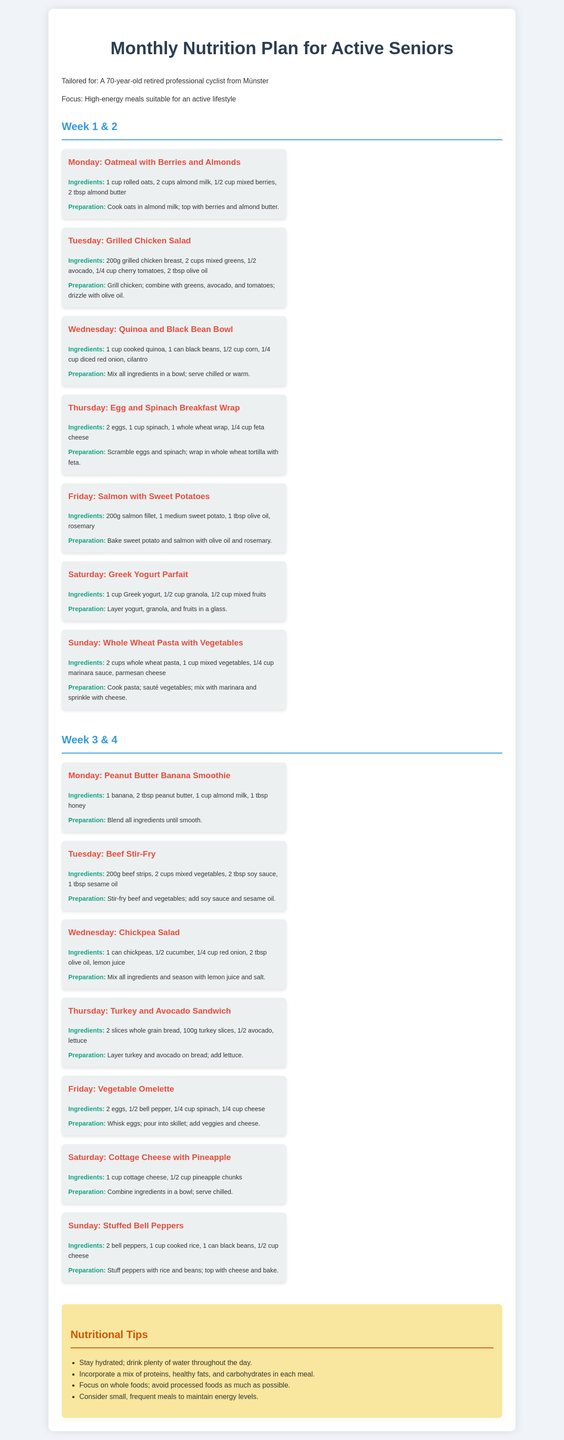What is the title of the document? The title indicates the main subject and purpose of the document, which is related to a nutritional plan for seniors.
Answer: Monthly Nutrition Plan for Active Seniors How many weeks are covered in the plan? The document outlines a plan that spans four weeks, divided into two sections.
Answer: 4 What day features a dish with mixed berries? The specific day associated with the dish recipe helps identify when to prepare it.
Answer: Monday What is a key ingredient in the Grilled Chicken Salad? The question identifies a main component of the salad recipe provided on a certain day.
Answer: Grilled chicken breast What type of bread is used for the Turkey and Avocado Sandwich? The question focuses on the specific type of bread mentioned in the sandwich recipe.
Answer: Whole grain What is one of the nutritional tips provided in the document? This inquiry seeks specific advice offered to improve dietary habits.
Answer: Stay hydrated How many ingredients are listed for the Vegetable Omelette? The question involves counting the ingredients listed for a particular recipe.
Answer: 4 What is the preparation method for the Peanut Butter Banana Smoothie? Understanding the preparation process is crucial for executing the recipe correctly.
Answer: Blend all ingredients until smooth What ingredient is used as a topping for the Stuffed Bell Peppers? This relates to a specific detail within the recipe for clarification on what goes on top of the dish.
Answer: Cheese 